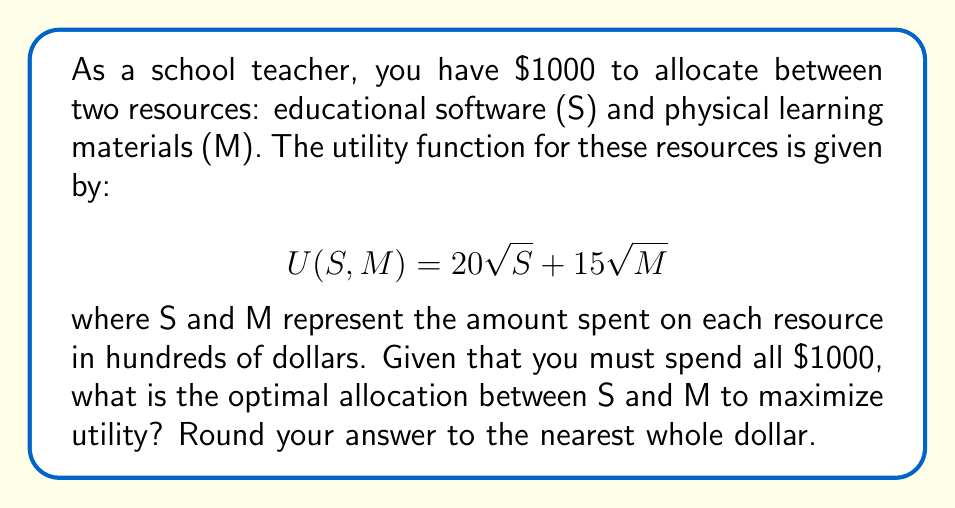Solve this math problem. To solve this problem, we'll use utility theory and the method of Lagrange multipliers:

1) First, we need to set up our constraint equation:
   $$S + M = 10$$ (since S and M are in hundreds of dollars)

2) Our utility function is:
   $$U(S,M) = 20\sqrt{S} + 15\sqrt{M}$$

3) We form the Lagrangian:
   $$L(S,M,\lambda) = 20\sqrt{S} + 15\sqrt{M} - \lambda(S + M - 10)$$

4) Now, we take partial derivatives and set them equal to zero:

   $$\frac{\partial L}{\partial S} = \frac{10}{\sqrt{S}} - \lambda = 0$$
   $$\frac{\partial L}{\partial M} = \frac{7.5}{\sqrt{M}} - \lambda = 0$$
   $$\frac{\partial L}{\partial \lambda} = S + M - 10 = 0$$

5) From the first two equations:
   $$\frac{10}{\sqrt{S}} = \frac{7.5}{\sqrt{M}}$$

6) Cross-multiplying:
   $$10\sqrt{M} = 7.5\sqrt{S}$$
   $$\frac{M}{S} = (\frac{3}{4})^2 = \frac{9}{16}$$

7) Using this ratio and the constraint equation:
   $$S + \frac{9}{16}S = 10$$
   $$\frac{25}{16}S = 10$$
   $$S = \frac{160}{25} = 6.4$$

8) Therefore:
   $$M = 10 - 6.4 = 3.6$$

9) Converting back to dollars:
   S = $640 and M = $360
Answer: The optimal allocation is $640 for educational software and $360 for physical learning materials. 